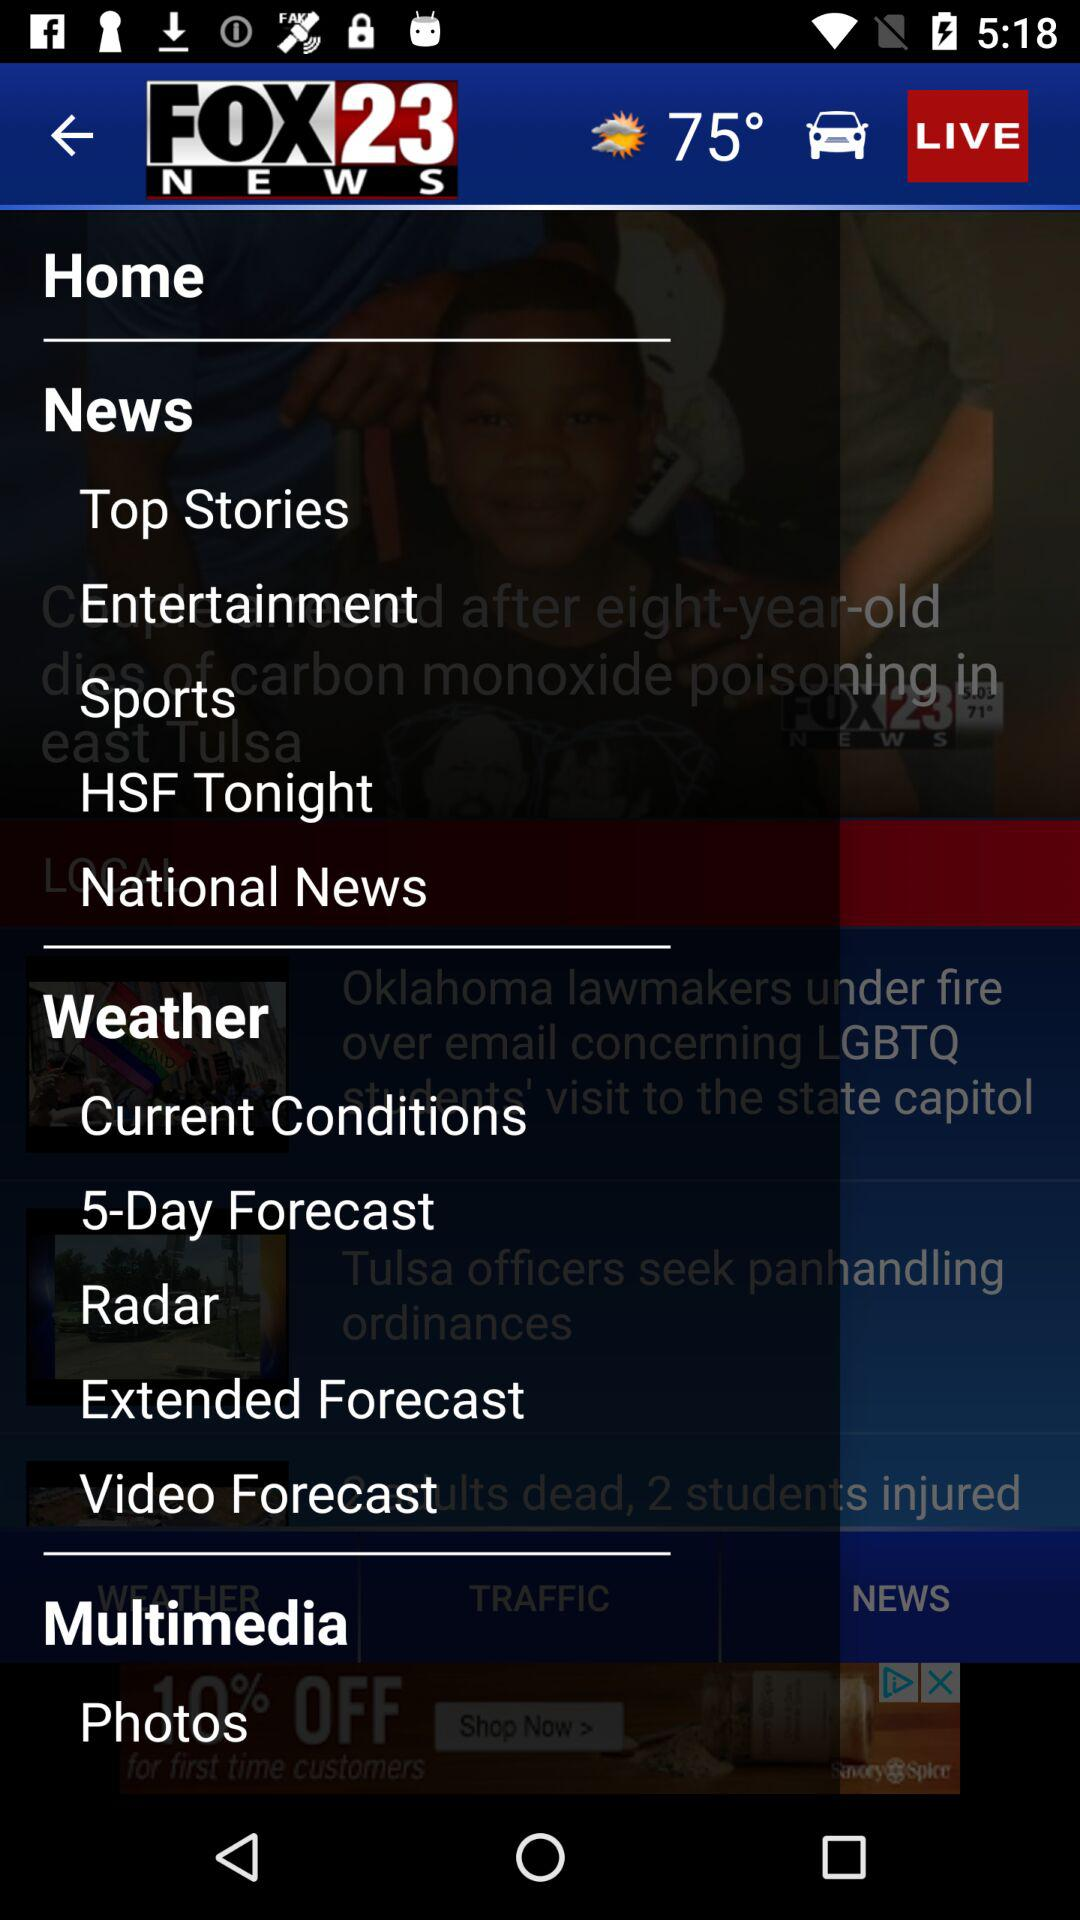How many notifications are there in "Sports"?
When the provided information is insufficient, respond with <no answer>. <no answer> 